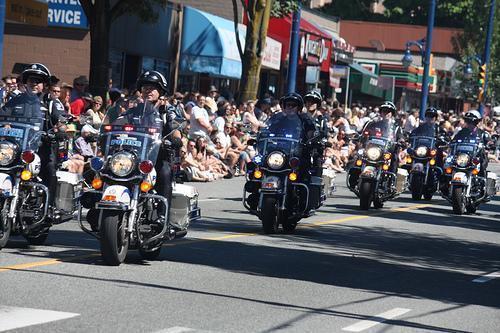Where do you go in this street if you want to buy candy?
Answer the question by selecting the correct answer among the 4 following choices.
Options: Restaurant, convenience store, shoes store, bank. Convenience store. 